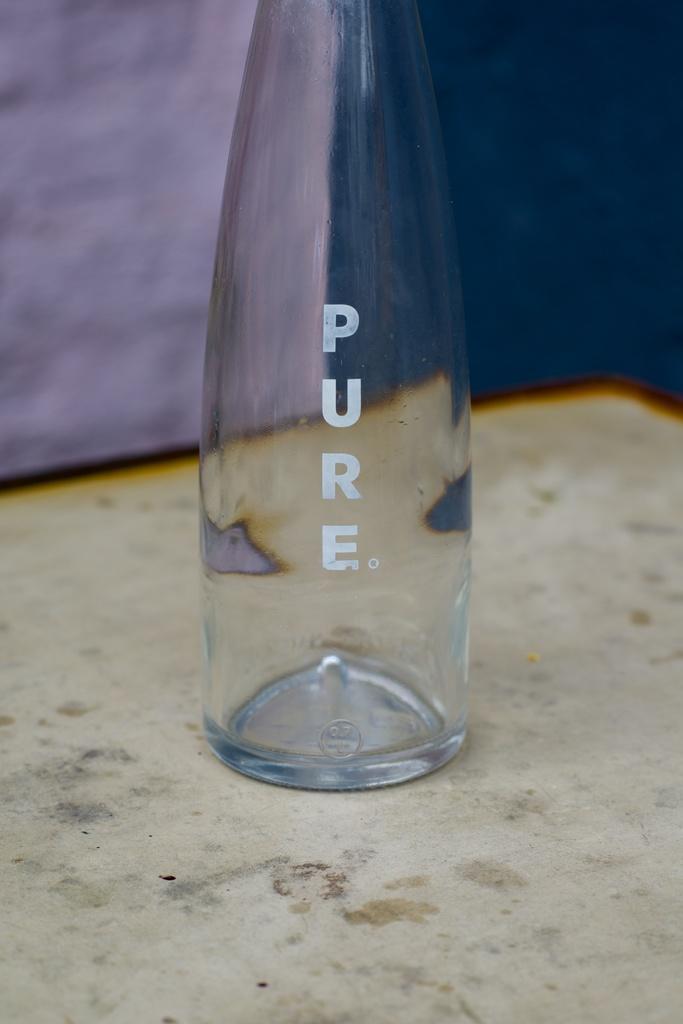Can you describe this image briefly? In this picture there is a bottle on the ground and some text printed on it. 